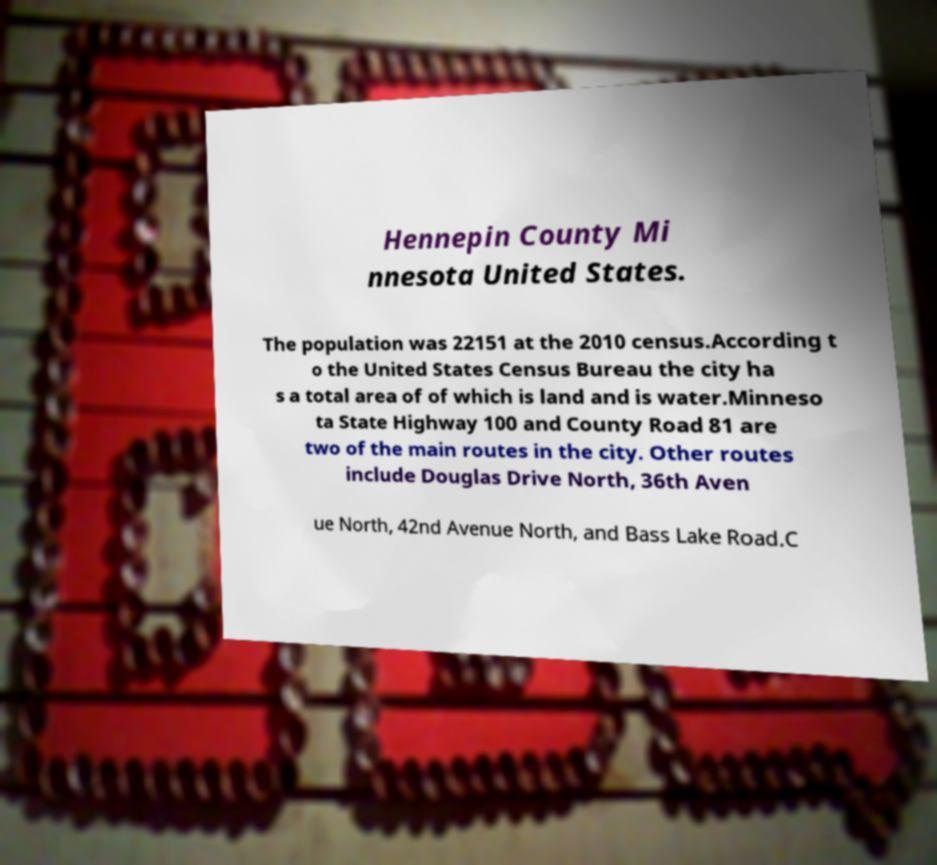Please identify and transcribe the text found in this image. Hennepin County Mi nnesota United States. The population was 22151 at the 2010 census.According t o the United States Census Bureau the city ha s a total area of of which is land and is water.Minneso ta State Highway 100 and County Road 81 are two of the main routes in the city. Other routes include Douglas Drive North, 36th Aven ue North, 42nd Avenue North, and Bass Lake Road.C 